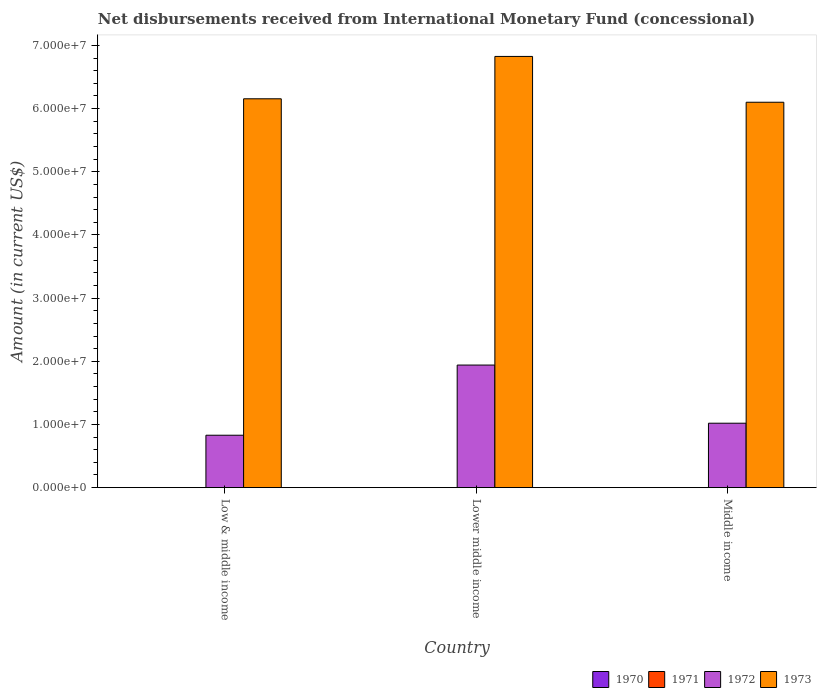How many groups of bars are there?
Ensure brevity in your answer.  3. Are the number of bars per tick equal to the number of legend labels?
Provide a succinct answer. No. Are the number of bars on each tick of the X-axis equal?
Your answer should be compact. Yes. How many bars are there on the 3rd tick from the left?
Offer a very short reply. 2. What is the label of the 2nd group of bars from the left?
Your response must be concise. Lower middle income. In how many cases, is the number of bars for a given country not equal to the number of legend labels?
Your response must be concise. 3. What is the amount of disbursements received from International Monetary Fund in 1972 in Lower middle income?
Offer a very short reply. 1.94e+07. Across all countries, what is the minimum amount of disbursements received from International Monetary Fund in 1972?
Your answer should be very brief. 8.30e+06. In which country was the amount of disbursements received from International Monetary Fund in 1972 maximum?
Your answer should be very brief. Lower middle income. What is the difference between the amount of disbursements received from International Monetary Fund in 1972 in Low & middle income and that in Middle income?
Make the answer very short. -1.90e+06. What is the difference between the amount of disbursements received from International Monetary Fund in 1973 in Low & middle income and the amount of disbursements received from International Monetary Fund in 1972 in Middle income?
Your response must be concise. 5.14e+07. What is the average amount of disbursements received from International Monetary Fund in 1971 per country?
Your response must be concise. 0. What is the difference between the amount of disbursements received from International Monetary Fund of/in 1972 and amount of disbursements received from International Monetary Fund of/in 1973 in Lower middle income?
Your answer should be very brief. -4.89e+07. What is the ratio of the amount of disbursements received from International Monetary Fund in 1973 in Lower middle income to that in Middle income?
Offer a very short reply. 1.12. Is the amount of disbursements received from International Monetary Fund in 1973 in Low & middle income less than that in Lower middle income?
Your answer should be compact. Yes. Is the difference between the amount of disbursements received from International Monetary Fund in 1972 in Lower middle income and Middle income greater than the difference between the amount of disbursements received from International Monetary Fund in 1973 in Lower middle income and Middle income?
Offer a very short reply. Yes. What is the difference between the highest and the second highest amount of disbursements received from International Monetary Fund in 1973?
Provide a short and direct response. -7.25e+06. What is the difference between the highest and the lowest amount of disbursements received from International Monetary Fund in 1973?
Provide a short and direct response. 7.25e+06. Is the sum of the amount of disbursements received from International Monetary Fund in 1973 in Lower middle income and Middle income greater than the maximum amount of disbursements received from International Monetary Fund in 1972 across all countries?
Your answer should be compact. Yes. Is it the case that in every country, the sum of the amount of disbursements received from International Monetary Fund in 1972 and amount of disbursements received from International Monetary Fund in 1973 is greater than the sum of amount of disbursements received from International Monetary Fund in 1970 and amount of disbursements received from International Monetary Fund in 1971?
Keep it short and to the point. No. Are all the bars in the graph horizontal?
Your answer should be compact. No. Are the values on the major ticks of Y-axis written in scientific E-notation?
Offer a terse response. Yes. Does the graph contain any zero values?
Make the answer very short. Yes. How many legend labels are there?
Give a very brief answer. 4. What is the title of the graph?
Give a very brief answer. Net disbursements received from International Monetary Fund (concessional). What is the label or title of the Y-axis?
Give a very brief answer. Amount (in current US$). What is the Amount (in current US$) in 1970 in Low & middle income?
Provide a succinct answer. 0. What is the Amount (in current US$) of 1971 in Low & middle income?
Make the answer very short. 0. What is the Amount (in current US$) in 1972 in Low & middle income?
Make the answer very short. 8.30e+06. What is the Amount (in current US$) in 1973 in Low & middle income?
Your answer should be very brief. 6.16e+07. What is the Amount (in current US$) of 1972 in Lower middle income?
Provide a succinct answer. 1.94e+07. What is the Amount (in current US$) of 1973 in Lower middle income?
Offer a terse response. 6.83e+07. What is the Amount (in current US$) in 1972 in Middle income?
Ensure brevity in your answer.  1.02e+07. What is the Amount (in current US$) in 1973 in Middle income?
Provide a succinct answer. 6.10e+07. Across all countries, what is the maximum Amount (in current US$) in 1972?
Ensure brevity in your answer.  1.94e+07. Across all countries, what is the maximum Amount (in current US$) in 1973?
Offer a terse response. 6.83e+07. Across all countries, what is the minimum Amount (in current US$) of 1972?
Your answer should be compact. 8.30e+06. Across all countries, what is the minimum Amount (in current US$) in 1973?
Your answer should be very brief. 6.10e+07. What is the total Amount (in current US$) of 1971 in the graph?
Offer a terse response. 0. What is the total Amount (in current US$) in 1972 in the graph?
Your response must be concise. 3.79e+07. What is the total Amount (in current US$) of 1973 in the graph?
Ensure brevity in your answer.  1.91e+08. What is the difference between the Amount (in current US$) in 1972 in Low & middle income and that in Lower middle income?
Offer a very short reply. -1.11e+07. What is the difference between the Amount (in current US$) in 1973 in Low & middle income and that in Lower middle income?
Provide a succinct answer. -6.70e+06. What is the difference between the Amount (in current US$) of 1972 in Low & middle income and that in Middle income?
Ensure brevity in your answer.  -1.90e+06. What is the difference between the Amount (in current US$) in 1973 in Low & middle income and that in Middle income?
Give a very brief answer. 5.46e+05. What is the difference between the Amount (in current US$) of 1972 in Lower middle income and that in Middle income?
Make the answer very short. 9.21e+06. What is the difference between the Amount (in current US$) in 1973 in Lower middle income and that in Middle income?
Your response must be concise. 7.25e+06. What is the difference between the Amount (in current US$) of 1972 in Low & middle income and the Amount (in current US$) of 1973 in Lower middle income?
Provide a succinct answer. -6.00e+07. What is the difference between the Amount (in current US$) in 1972 in Low & middle income and the Amount (in current US$) in 1973 in Middle income?
Give a very brief answer. -5.27e+07. What is the difference between the Amount (in current US$) of 1972 in Lower middle income and the Amount (in current US$) of 1973 in Middle income?
Offer a very short reply. -4.16e+07. What is the average Amount (in current US$) of 1970 per country?
Give a very brief answer. 0. What is the average Amount (in current US$) of 1972 per country?
Keep it short and to the point. 1.26e+07. What is the average Amount (in current US$) of 1973 per country?
Offer a terse response. 6.36e+07. What is the difference between the Amount (in current US$) in 1972 and Amount (in current US$) in 1973 in Low & middle income?
Make the answer very short. -5.33e+07. What is the difference between the Amount (in current US$) in 1972 and Amount (in current US$) in 1973 in Lower middle income?
Provide a succinct answer. -4.89e+07. What is the difference between the Amount (in current US$) of 1972 and Amount (in current US$) of 1973 in Middle income?
Your answer should be compact. -5.08e+07. What is the ratio of the Amount (in current US$) in 1972 in Low & middle income to that in Lower middle income?
Keep it short and to the point. 0.43. What is the ratio of the Amount (in current US$) in 1973 in Low & middle income to that in Lower middle income?
Your response must be concise. 0.9. What is the ratio of the Amount (in current US$) of 1972 in Low & middle income to that in Middle income?
Make the answer very short. 0.81. What is the ratio of the Amount (in current US$) in 1973 in Low & middle income to that in Middle income?
Offer a terse response. 1.01. What is the ratio of the Amount (in current US$) of 1972 in Lower middle income to that in Middle income?
Ensure brevity in your answer.  1.9. What is the ratio of the Amount (in current US$) of 1973 in Lower middle income to that in Middle income?
Keep it short and to the point. 1.12. What is the difference between the highest and the second highest Amount (in current US$) of 1972?
Make the answer very short. 9.21e+06. What is the difference between the highest and the second highest Amount (in current US$) of 1973?
Provide a succinct answer. 6.70e+06. What is the difference between the highest and the lowest Amount (in current US$) in 1972?
Offer a terse response. 1.11e+07. What is the difference between the highest and the lowest Amount (in current US$) in 1973?
Give a very brief answer. 7.25e+06. 